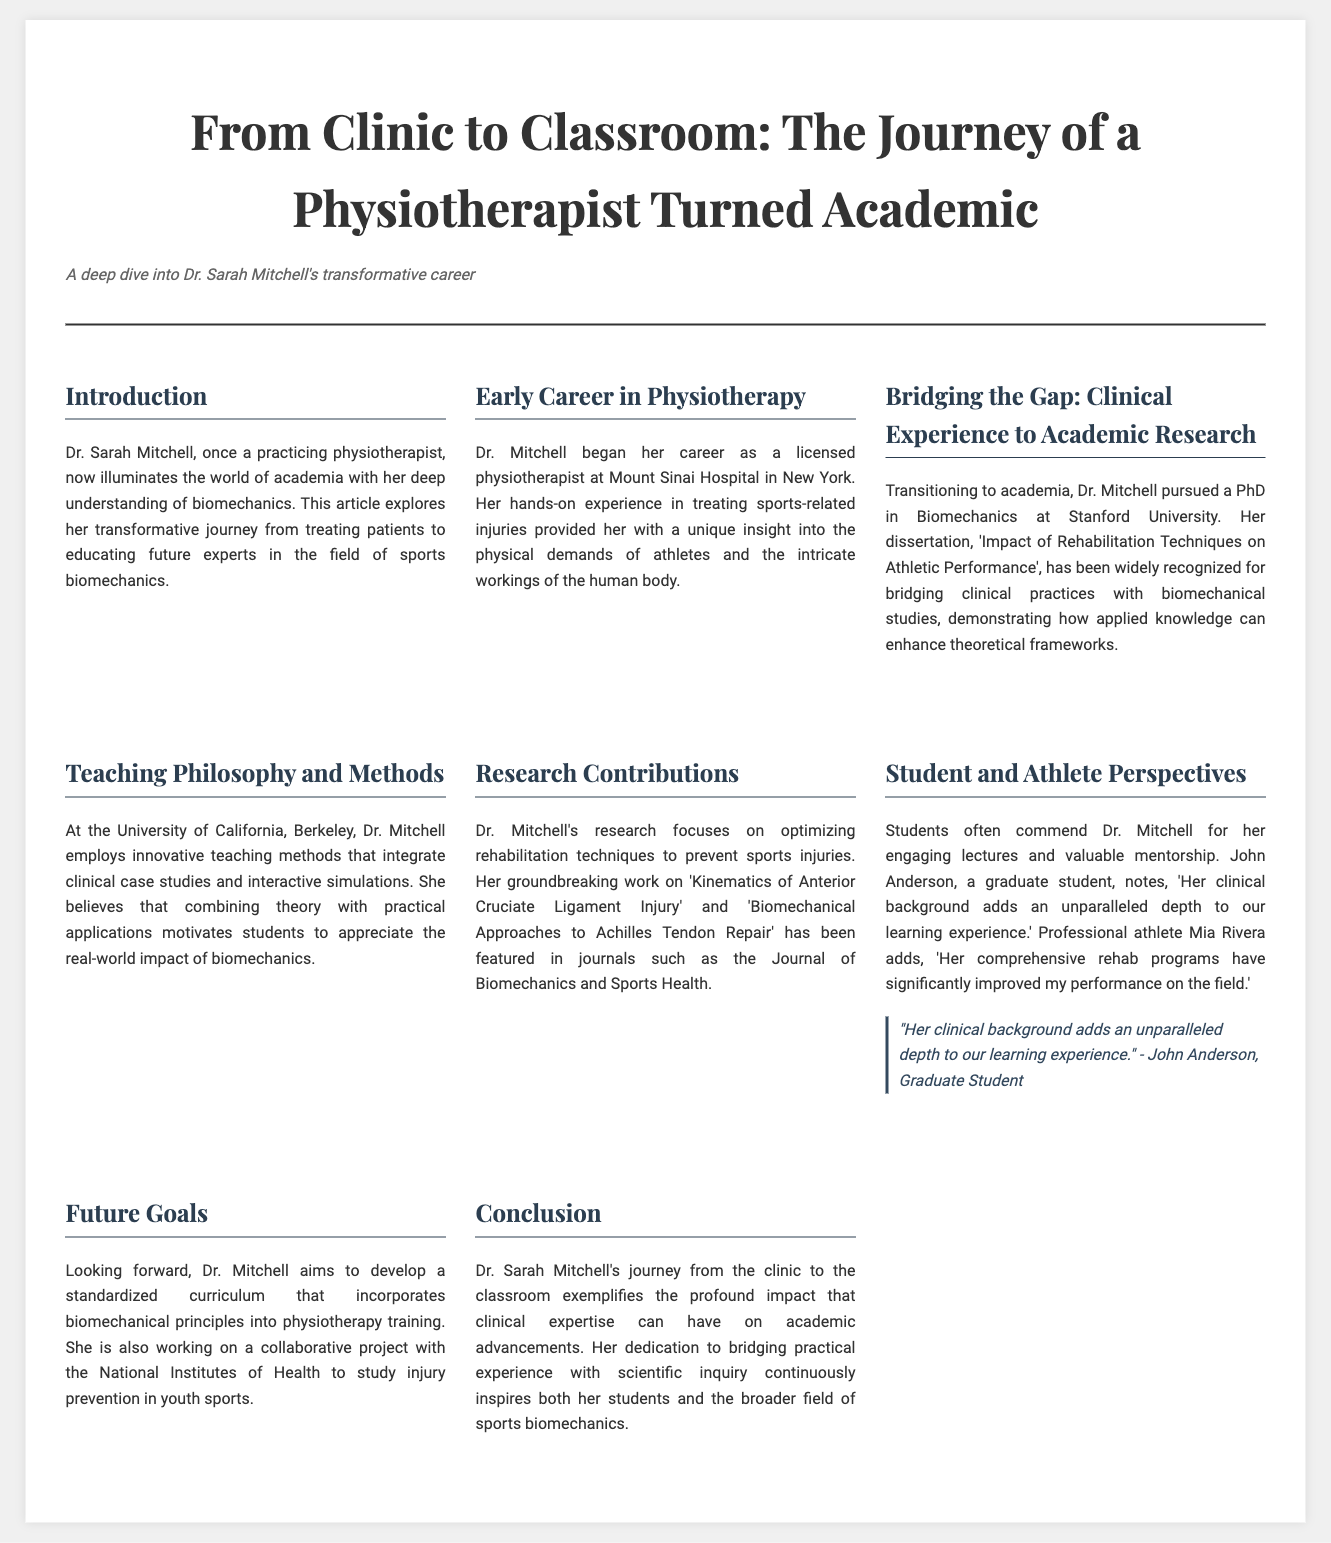What is the name of the academic featured in the article? The article centers around Dr. Sarah Mitchell, a physiotherapist turned academic.
Answer: Dr. Sarah Mitchell Where did Dr. Mitchell obtain her PhD? The document states that Dr. Mitchell pursued her PhD at Stanford University.
Answer: Stanford University What is the title of Dr. Mitchell's dissertation? The title of her dissertation is 'Impact of Rehabilitation Techniques on Athletic Performance', as mentioned in the article.
Answer: Impact of Rehabilitation Techniques on Athletic Performance What teaching methods does Dr. Mitchell use? Dr. Mitchell employs innovative methods that integrate clinical case studies and interactive simulations in her teaching.
Answer: Clinical case studies and interactive simulations What is a future goal of Dr. Mitchell? The document highlights her aim to develop a standardized curriculum that incorporates biomechanical principles into physiotherapy training.
Answer: Develop a standardized curriculum Who is John Anderson? John Anderson is identified as a graduate student who commends Dr. Mitchell for her engaging lectures and mentorship.
Answer: Graduate student What is one of Dr. Mitchell's research focuses? The article mentions that she focuses on optimizing rehabilitation techniques to prevent sports injuries.
Answer: Optimizing rehabilitation techniques Which journals have featured Dr. Mitchell's work? Dr. Mitchell's work has been featured in the Journal of Biomechanics and Sports Health, according to the article.
Answer: Journal of Biomechanics and Sports Health 